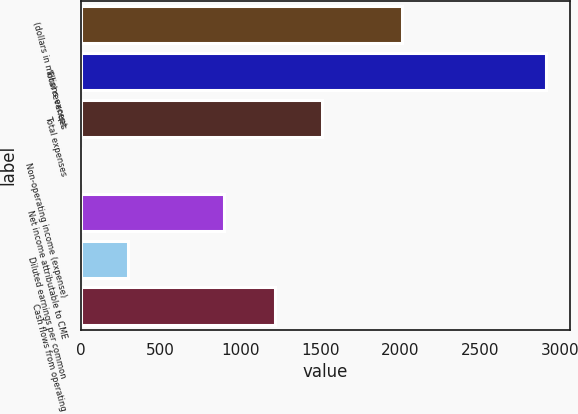<chart> <loc_0><loc_0><loc_500><loc_500><bar_chart><fcel>(dollars in millions except<fcel>Total revenues<fcel>Total expenses<fcel>Non-operating income (expense)<fcel>Net income attributable to CME<fcel>Diluted earnings per common<fcel>Cash flows from operating<nl><fcel>2012<fcel>2914.6<fcel>1508.12<fcel>1.4<fcel>896.3<fcel>292.72<fcel>1216.8<nl></chart> 